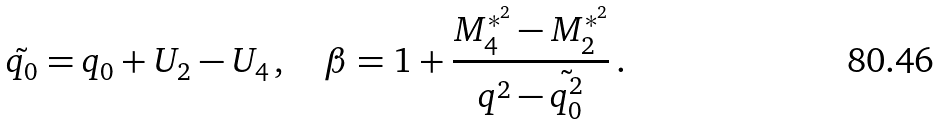<formula> <loc_0><loc_0><loc_500><loc_500>\tilde { q _ { 0 } } = q _ { 0 } + U _ { 2 } - U _ { 4 } \, , \quad \beta = 1 + \frac { M ^ { * ^ { 2 } } _ { 4 } - M ^ { * ^ { 2 } } _ { 2 } } { q ^ { 2 } - \tilde { q _ { 0 } ^ { 2 } } } \, .</formula> 